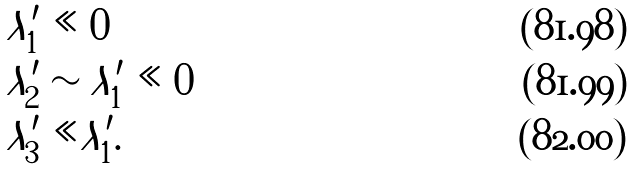Convert formula to latex. <formula><loc_0><loc_0><loc_500><loc_500>& \lambda _ { 1 } ^ { \prime } \ll 0 \\ & \lambda _ { 2 } ^ { \prime } \sim \lambda _ { 1 } ^ { \prime } \ll 0 \\ & | \lambda _ { 3 } ^ { \prime } | \ll | \lambda _ { 1 } ^ { \prime } | .</formula> 